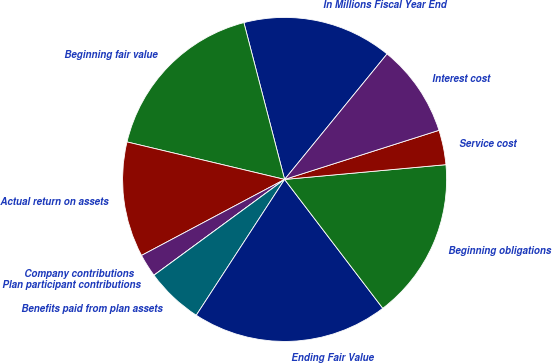Convert chart to OTSL. <chart><loc_0><loc_0><loc_500><loc_500><pie_chart><fcel>In Millions Fiscal Year End<fcel>Beginning fair value<fcel>Actual return on assets<fcel>Company contributions<fcel>Plan participant contributions<fcel>Benefits paid from plan assets<fcel>Ending Fair Value<fcel>Beginning obligations<fcel>Service cost<fcel>Interest cost<nl><fcel>14.94%<fcel>17.24%<fcel>11.49%<fcel>2.3%<fcel>0.0%<fcel>5.75%<fcel>19.54%<fcel>16.09%<fcel>3.45%<fcel>9.2%<nl></chart> 